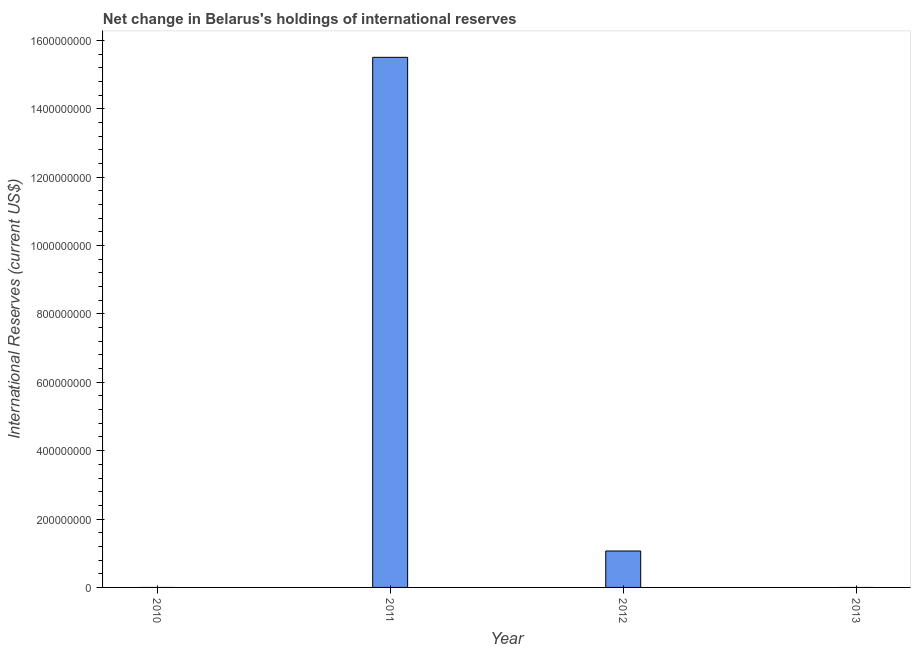Does the graph contain any zero values?
Provide a succinct answer. Yes. What is the title of the graph?
Keep it short and to the point. Net change in Belarus's holdings of international reserves. What is the label or title of the Y-axis?
Provide a succinct answer. International Reserves (current US$). Across all years, what is the maximum reserves and related items?
Ensure brevity in your answer.  1.55e+09. Across all years, what is the minimum reserves and related items?
Make the answer very short. 0. In which year was the reserves and related items maximum?
Provide a short and direct response. 2011. What is the sum of the reserves and related items?
Provide a succinct answer. 1.66e+09. What is the difference between the reserves and related items in 2011 and 2012?
Keep it short and to the point. 1.44e+09. What is the average reserves and related items per year?
Give a very brief answer. 4.14e+08. What is the median reserves and related items?
Your answer should be very brief. 5.33e+07. In how many years, is the reserves and related items greater than 720000000 US$?
Your answer should be compact. 1. What is the ratio of the reserves and related items in 2011 to that in 2012?
Keep it short and to the point. 14.55. Is the reserves and related items in 2011 less than that in 2012?
Provide a short and direct response. No. Is the sum of the reserves and related items in 2011 and 2012 greater than the maximum reserves and related items across all years?
Your answer should be compact. Yes. What is the difference between the highest and the lowest reserves and related items?
Your answer should be compact. 1.55e+09. In how many years, is the reserves and related items greater than the average reserves and related items taken over all years?
Your response must be concise. 1. Are all the bars in the graph horizontal?
Your response must be concise. No. How many years are there in the graph?
Offer a terse response. 4. What is the International Reserves (current US$) in 2011?
Offer a very short reply. 1.55e+09. What is the International Reserves (current US$) in 2012?
Offer a very short reply. 1.07e+08. What is the difference between the International Reserves (current US$) in 2011 and 2012?
Provide a short and direct response. 1.44e+09. What is the ratio of the International Reserves (current US$) in 2011 to that in 2012?
Offer a very short reply. 14.55. 